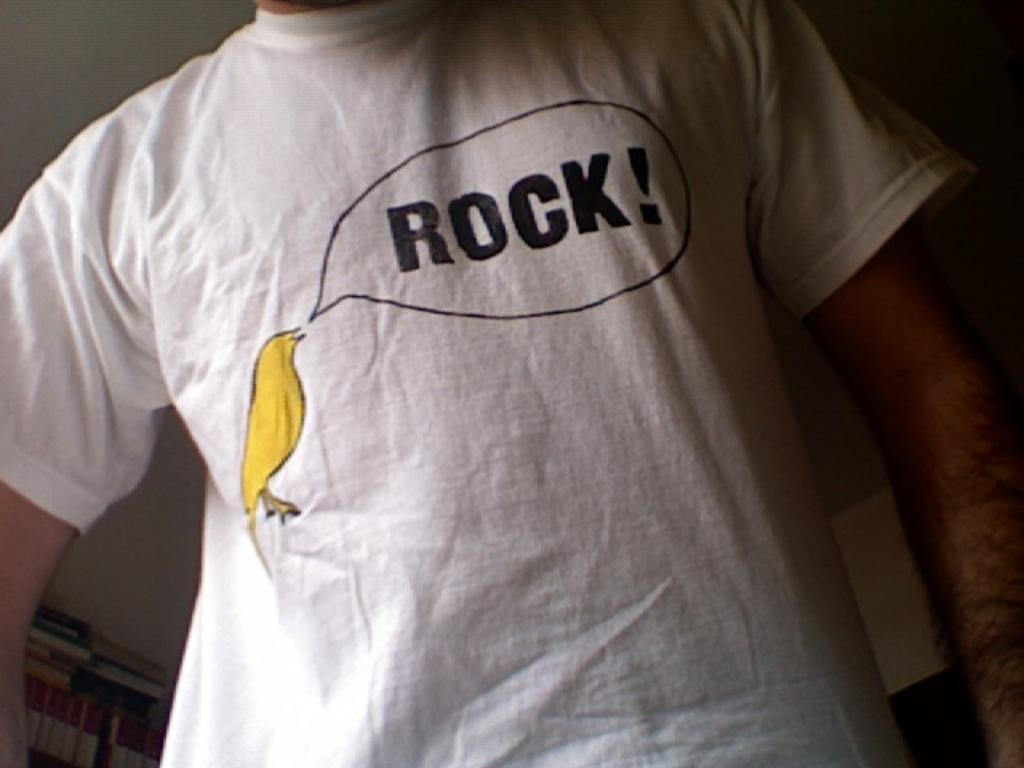<image>
Present a compact description of the photo's key features. someone wearing white shirt that has yellow bird saying rock! 